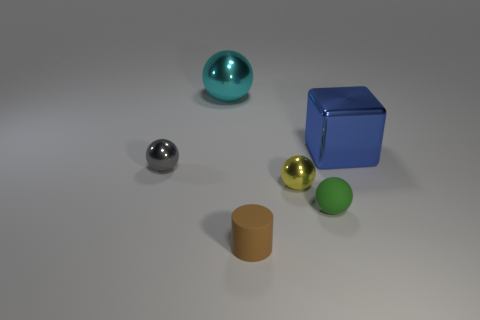Do the tiny cylinder and the tiny ball on the left side of the large cyan metal thing have the same material?
Make the answer very short. No. What number of other things are there of the same material as the cylinder
Give a very brief answer. 1. Are the thing that is behind the big blue metal cube and the cylinder made of the same material?
Your answer should be very brief. No. Is there a purple matte thing that has the same size as the gray metallic ball?
Provide a succinct answer. No. What is the material of the green object that is the same size as the brown cylinder?
Offer a very short reply. Rubber. The thing that is in front of the green rubber ball has what shape?
Offer a terse response. Cylinder. Are the large object left of the tiny green matte sphere and the ball that is right of the small yellow sphere made of the same material?
Your response must be concise. No. How many other rubber things are the same shape as the big blue object?
Provide a succinct answer. 0. How many things are either brown matte cylinders or balls on the right side of the brown matte cylinder?
Your answer should be very brief. 3. What material is the small brown thing?
Make the answer very short. Rubber. 